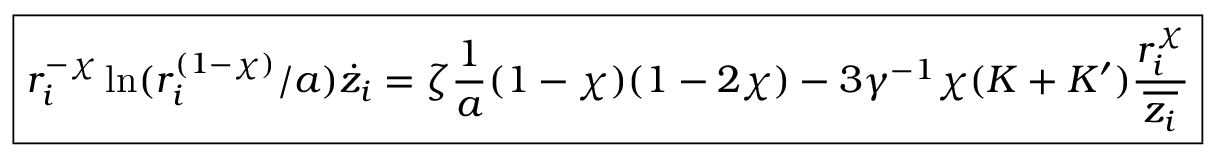<formula> <loc_0><loc_0><loc_500><loc_500>\boxed { r _ { i } ^ { - \chi } \ln ( r _ { i } ^ { ( 1 - \chi ) } / a ) \dot { z } _ { i } = \zeta \frac { 1 } { a } ( 1 - \chi ) ( 1 - 2 \chi ) - 3 \gamma ^ { - 1 } \chi ( K + K ^ { \prime } ) \frac { r _ { i } ^ { \chi } } { \overline { { z _ { i } } } } }</formula> 